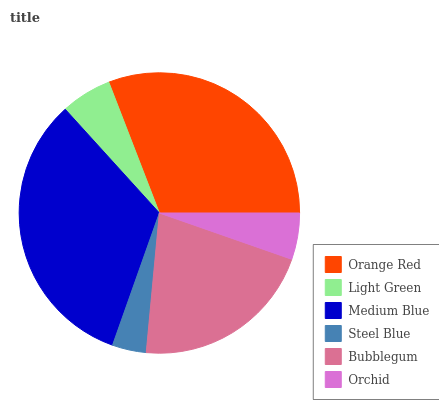Is Steel Blue the minimum?
Answer yes or no. Yes. Is Medium Blue the maximum?
Answer yes or no. Yes. Is Light Green the minimum?
Answer yes or no. No. Is Light Green the maximum?
Answer yes or no. No. Is Orange Red greater than Light Green?
Answer yes or no. Yes. Is Light Green less than Orange Red?
Answer yes or no. Yes. Is Light Green greater than Orange Red?
Answer yes or no. No. Is Orange Red less than Light Green?
Answer yes or no. No. Is Bubblegum the high median?
Answer yes or no. Yes. Is Light Green the low median?
Answer yes or no. Yes. Is Light Green the high median?
Answer yes or no. No. Is Bubblegum the low median?
Answer yes or no. No. 